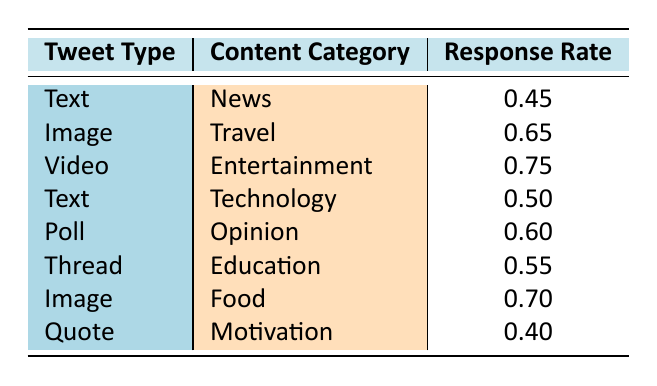What is the response rate for Video in the Entertainment category? The table indicates that the response rate for Video, categorized under Entertainment, is explicitly listed as 0.75.
Answer: 0.75 Which tweet type has the highest response rate? By reviewing each response rate, Video under Entertainment shows the highest response rate of 0.75, compared to other tweet types listed.
Answer: Video Is the response rate for Quote in the Motivation category higher than that for Text in the News category? The response rate for Quote (0.40) is compared against Text in the News (0.45). Since 0.40 is less than 0.45, the statement is false.
Answer: No What is the average response rate for Image posts? The response rates for Image posts are 0.65 (Travel) and 0.70 (Food). The average is (0.65 + 0.70) / 2 = 0.675.
Answer: 0.675 Are there any types of tweets in the Education category that have a response rate lower than 0.55? The only tweet type listed under Education is Thread, which has a response rate of 0.55. Thus, there are no Education posts with a lower rate.
Answer: No What is the difference between the highest and lowest response rates? The highest response rate is 0.75 (Video, Entertainment) and the lowest is 0.40 (Quote, Motivation). The difference is 0.75 - 0.40 = 0.35.
Answer: 0.35 Which content category has a higher response rate, Travel or Food? Travel has a response rate of 0.65, and Food has a response rate of 0.70. Comparing these, Food has a higher response rate.
Answer: Food How many tweet types have a response rate of 0.60 or higher? The tweet types that meet this criterion are Video (0.75), Image (Travel 0.65), Poll (0.60), and Image (Food 0.70). That's a total of 4 tweet types.
Answer: 4 